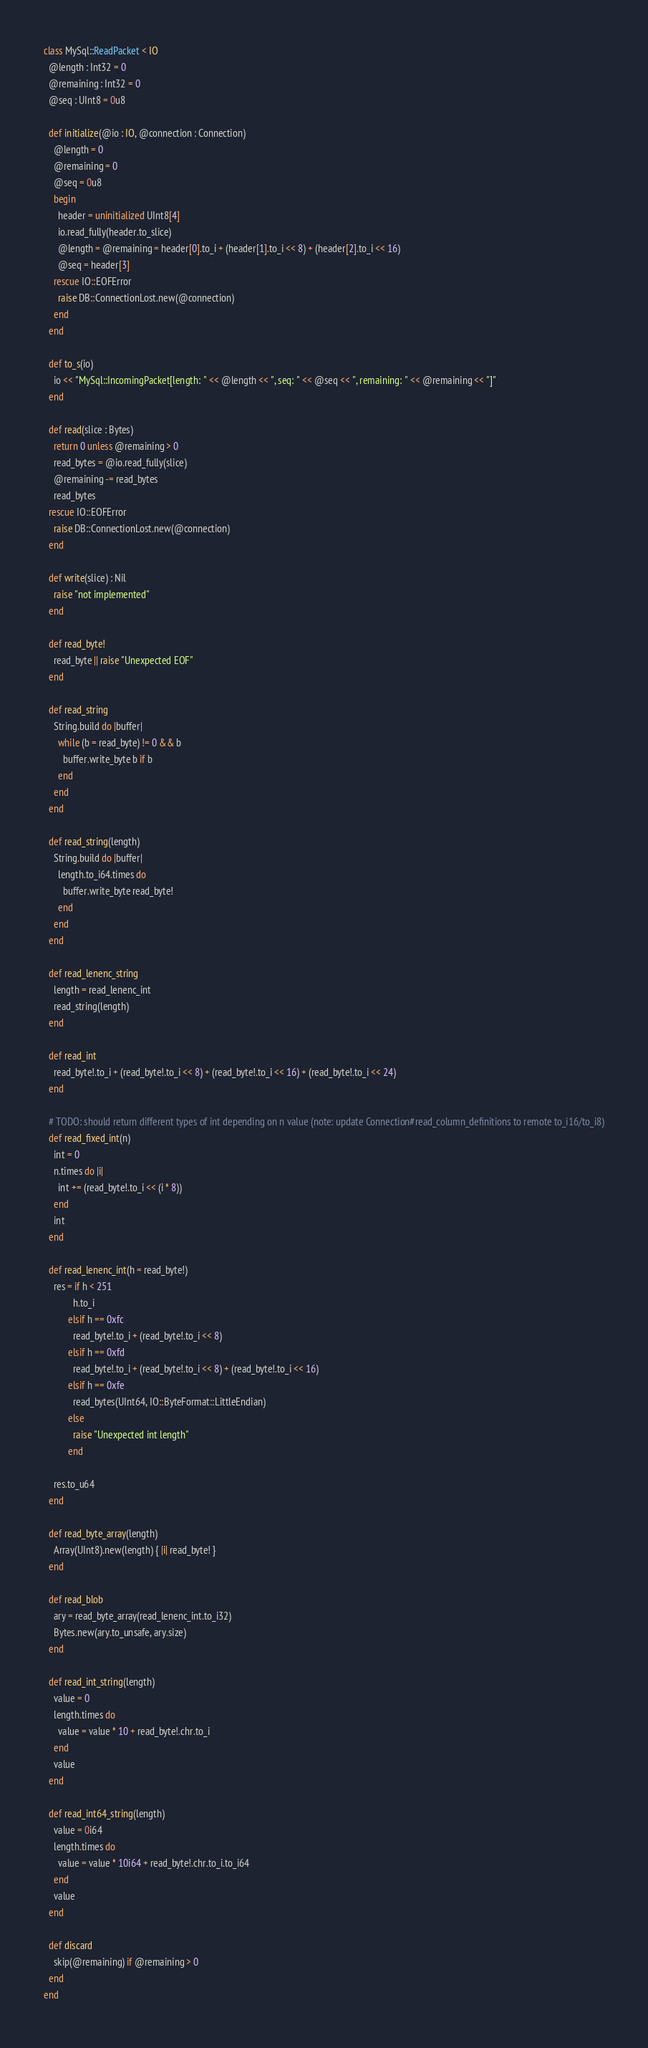<code> <loc_0><loc_0><loc_500><loc_500><_Crystal_>class MySql::ReadPacket < IO
  @length : Int32 = 0
  @remaining : Int32 = 0
  @seq : UInt8 = 0u8

  def initialize(@io : IO, @connection : Connection)
    @length = 0
    @remaining = 0
    @seq = 0u8
    begin
      header = uninitialized UInt8[4]
      io.read_fully(header.to_slice)
      @length = @remaining = header[0].to_i + (header[1].to_i << 8) + (header[2].to_i << 16)
      @seq = header[3]
    rescue IO::EOFError
      raise DB::ConnectionLost.new(@connection)
    end
  end

  def to_s(io)
    io << "MySql::IncomingPacket[length: " << @length << ", seq: " << @seq << ", remaining: " << @remaining << "]"
  end

  def read(slice : Bytes)
    return 0 unless @remaining > 0
    read_bytes = @io.read_fully(slice)
    @remaining -= read_bytes
    read_bytes
  rescue IO::EOFError
    raise DB::ConnectionLost.new(@connection)
  end

  def write(slice) : Nil
    raise "not implemented"
  end

  def read_byte!
    read_byte || raise "Unexpected EOF"
  end

  def read_string
    String.build do |buffer|
      while (b = read_byte) != 0 && b
        buffer.write_byte b if b
      end
    end
  end

  def read_string(length)
    String.build do |buffer|
      length.to_i64.times do
        buffer.write_byte read_byte!
      end
    end
  end

  def read_lenenc_string
    length = read_lenenc_int
    read_string(length)
  end

  def read_int
    read_byte!.to_i + (read_byte!.to_i << 8) + (read_byte!.to_i << 16) + (read_byte!.to_i << 24)
  end

  # TODO: should return different types of int depending on n value (note: update Connection#read_column_definitions to remote to_i16/to_i8)
  def read_fixed_int(n)
    int = 0
    n.times do |i|
      int += (read_byte!.to_i << (i * 8))
    end
    int
  end

  def read_lenenc_int(h = read_byte!)
    res = if h < 251
            h.to_i
          elsif h == 0xfc
            read_byte!.to_i + (read_byte!.to_i << 8)
          elsif h == 0xfd
            read_byte!.to_i + (read_byte!.to_i << 8) + (read_byte!.to_i << 16)
          elsif h == 0xfe
            read_bytes(UInt64, IO::ByteFormat::LittleEndian)
          else
            raise "Unexpected int length"
          end

    res.to_u64
  end

  def read_byte_array(length)
    Array(UInt8).new(length) { |i| read_byte! }
  end

  def read_blob
    ary = read_byte_array(read_lenenc_int.to_i32)
    Bytes.new(ary.to_unsafe, ary.size)
  end

  def read_int_string(length)
    value = 0
    length.times do
      value = value * 10 + read_byte!.chr.to_i
    end
    value
  end

  def read_int64_string(length)
    value = 0i64
    length.times do
      value = value * 10i64 + read_byte!.chr.to_i.to_i64
    end
    value
  end

  def discard
    skip(@remaining) if @remaining > 0
  end
end
</code> 